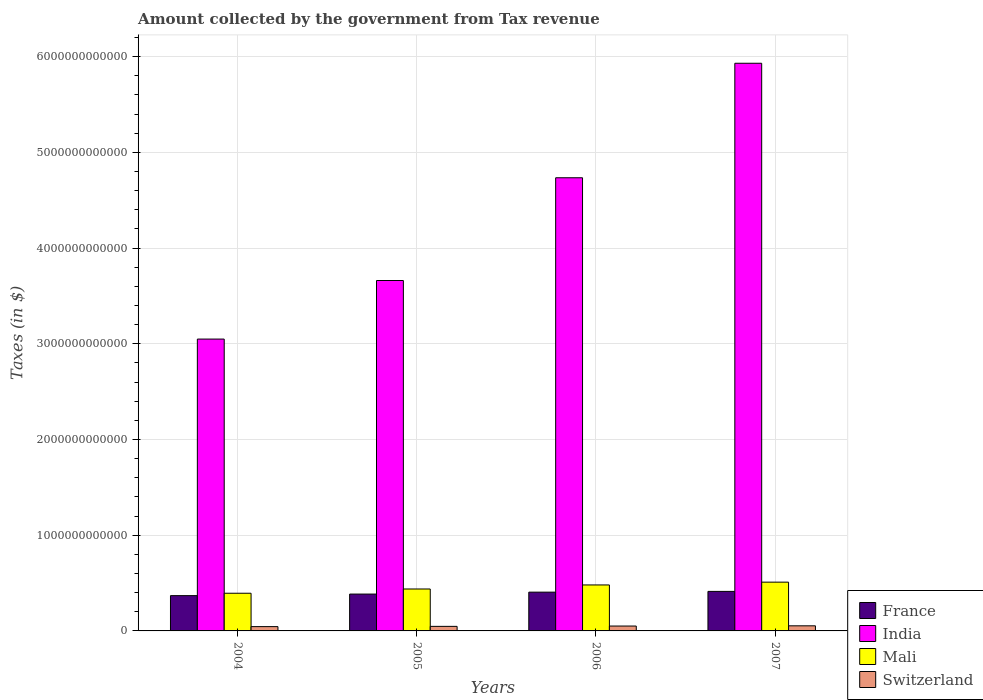Are the number of bars on each tick of the X-axis equal?
Your answer should be very brief. Yes. How many bars are there on the 3rd tick from the left?
Offer a terse response. 4. What is the label of the 3rd group of bars from the left?
Provide a succinct answer. 2006. In how many cases, is the number of bars for a given year not equal to the number of legend labels?
Offer a terse response. 0. What is the amount collected by the government from tax revenue in Switzerland in 2006?
Make the answer very short. 5.10e+1. Across all years, what is the maximum amount collected by the government from tax revenue in France?
Your response must be concise. 4.13e+11. Across all years, what is the minimum amount collected by the government from tax revenue in Mali?
Offer a very short reply. 3.94e+11. In which year was the amount collected by the government from tax revenue in Switzerland minimum?
Offer a very short reply. 2004. What is the total amount collected by the government from tax revenue in Switzerland in the graph?
Make the answer very short. 1.97e+11. What is the difference between the amount collected by the government from tax revenue in Mali in 2005 and that in 2007?
Offer a terse response. -7.16e+1. What is the difference between the amount collected by the government from tax revenue in India in 2005 and the amount collected by the government from tax revenue in France in 2004?
Offer a terse response. 3.29e+12. What is the average amount collected by the government from tax revenue in Mali per year?
Keep it short and to the point. 4.55e+11. In the year 2004, what is the difference between the amount collected by the government from tax revenue in France and amount collected by the government from tax revenue in Mali?
Ensure brevity in your answer.  -2.50e+1. In how many years, is the amount collected by the government from tax revenue in Mali greater than 1600000000000 $?
Your response must be concise. 0. What is the ratio of the amount collected by the government from tax revenue in Switzerland in 2005 to that in 2007?
Your response must be concise. 0.89. What is the difference between the highest and the second highest amount collected by the government from tax revenue in India?
Provide a succinct answer. 1.20e+12. What is the difference between the highest and the lowest amount collected by the government from tax revenue in Mali?
Your answer should be compact. 1.16e+11. What does the 4th bar from the left in 2005 represents?
Your response must be concise. Switzerland. What does the 2nd bar from the right in 2006 represents?
Provide a succinct answer. Mali. How many bars are there?
Your response must be concise. 16. What is the difference between two consecutive major ticks on the Y-axis?
Give a very brief answer. 1.00e+12. Are the values on the major ticks of Y-axis written in scientific E-notation?
Give a very brief answer. No. Does the graph contain grids?
Offer a terse response. Yes. How many legend labels are there?
Keep it short and to the point. 4. What is the title of the graph?
Offer a terse response. Amount collected by the government from Tax revenue. What is the label or title of the X-axis?
Ensure brevity in your answer.  Years. What is the label or title of the Y-axis?
Provide a short and direct response. Taxes (in $). What is the Taxes (in $) in France in 2004?
Your answer should be compact. 3.69e+11. What is the Taxes (in $) of India in 2004?
Your answer should be very brief. 3.05e+12. What is the Taxes (in $) in Mali in 2004?
Provide a succinct answer. 3.94e+11. What is the Taxes (in $) in Switzerland in 2004?
Your answer should be very brief. 4.49e+1. What is the Taxes (in $) of France in 2005?
Your answer should be very brief. 3.85e+11. What is the Taxes (in $) in India in 2005?
Offer a terse response. 3.66e+12. What is the Taxes (in $) of Mali in 2005?
Ensure brevity in your answer.  4.38e+11. What is the Taxes (in $) of Switzerland in 2005?
Your answer should be compact. 4.76e+1. What is the Taxes (in $) of France in 2006?
Provide a succinct answer. 4.05e+11. What is the Taxes (in $) of India in 2006?
Your response must be concise. 4.74e+12. What is the Taxes (in $) in Mali in 2006?
Give a very brief answer. 4.80e+11. What is the Taxes (in $) in Switzerland in 2006?
Keep it short and to the point. 5.10e+1. What is the Taxes (in $) in France in 2007?
Keep it short and to the point. 4.13e+11. What is the Taxes (in $) in India in 2007?
Give a very brief answer. 5.93e+12. What is the Taxes (in $) in Mali in 2007?
Give a very brief answer. 5.10e+11. What is the Taxes (in $) in Switzerland in 2007?
Your answer should be compact. 5.34e+1. Across all years, what is the maximum Taxes (in $) of France?
Your answer should be compact. 4.13e+11. Across all years, what is the maximum Taxes (in $) in India?
Your answer should be compact. 5.93e+12. Across all years, what is the maximum Taxes (in $) in Mali?
Offer a very short reply. 5.10e+11. Across all years, what is the maximum Taxes (in $) of Switzerland?
Offer a very short reply. 5.34e+1. Across all years, what is the minimum Taxes (in $) of France?
Ensure brevity in your answer.  3.69e+11. Across all years, what is the minimum Taxes (in $) of India?
Provide a succinct answer. 3.05e+12. Across all years, what is the minimum Taxes (in $) in Mali?
Keep it short and to the point. 3.94e+11. Across all years, what is the minimum Taxes (in $) in Switzerland?
Provide a succinct answer. 4.49e+1. What is the total Taxes (in $) of France in the graph?
Offer a terse response. 1.57e+12. What is the total Taxes (in $) in India in the graph?
Your response must be concise. 1.74e+13. What is the total Taxes (in $) in Mali in the graph?
Provide a short and direct response. 1.82e+12. What is the total Taxes (in $) in Switzerland in the graph?
Ensure brevity in your answer.  1.97e+11. What is the difference between the Taxes (in $) in France in 2004 and that in 2005?
Your answer should be very brief. -1.64e+1. What is the difference between the Taxes (in $) in India in 2004 and that in 2005?
Ensure brevity in your answer.  -6.12e+11. What is the difference between the Taxes (in $) in Mali in 2004 and that in 2005?
Your answer should be compact. -4.44e+1. What is the difference between the Taxes (in $) of Switzerland in 2004 and that in 2005?
Keep it short and to the point. -2.68e+09. What is the difference between the Taxes (in $) in France in 2004 and that in 2006?
Offer a terse response. -3.65e+1. What is the difference between the Taxes (in $) of India in 2004 and that in 2006?
Your answer should be compact. -1.69e+12. What is the difference between the Taxes (in $) of Mali in 2004 and that in 2006?
Your response must be concise. -8.68e+1. What is the difference between the Taxes (in $) in Switzerland in 2004 and that in 2006?
Offer a terse response. -6.07e+09. What is the difference between the Taxes (in $) in France in 2004 and that in 2007?
Keep it short and to the point. -4.43e+1. What is the difference between the Taxes (in $) of India in 2004 and that in 2007?
Keep it short and to the point. -2.88e+12. What is the difference between the Taxes (in $) of Mali in 2004 and that in 2007?
Your answer should be very brief. -1.16e+11. What is the difference between the Taxes (in $) of Switzerland in 2004 and that in 2007?
Keep it short and to the point. -8.41e+09. What is the difference between the Taxes (in $) of France in 2005 and that in 2006?
Provide a succinct answer. -2.01e+1. What is the difference between the Taxes (in $) in India in 2005 and that in 2006?
Your answer should be very brief. -1.07e+12. What is the difference between the Taxes (in $) of Mali in 2005 and that in 2006?
Your response must be concise. -4.23e+1. What is the difference between the Taxes (in $) of Switzerland in 2005 and that in 2006?
Give a very brief answer. -3.39e+09. What is the difference between the Taxes (in $) in France in 2005 and that in 2007?
Give a very brief answer. -2.78e+1. What is the difference between the Taxes (in $) of India in 2005 and that in 2007?
Your answer should be compact. -2.27e+12. What is the difference between the Taxes (in $) in Mali in 2005 and that in 2007?
Your answer should be very brief. -7.16e+1. What is the difference between the Taxes (in $) in Switzerland in 2005 and that in 2007?
Offer a terse response. -5.73e+09. What is the difference between the Taxes (in $) in France in 2006 and that in 2007?
Provide a succinct answer. -7.79e+09. What is the difference between the Taxes (in $) of India in 2006 and that in 2007?
Make the answer very short. -1.20e+12. What is the difference between the Taxes (in $) of Mali in 2006 and that in 2007?
Your response must be concise. -2.93e+1. What is the difference between the Taxes (in $) of Switzerland in 2006 and that in 2007?
Make the answer very short. -2.34e+09. What is the difference between the Taxes (in $) in France in 2004 and the Taxes (in $) in India in 2005?
Make the answer very short. -3.29e+12. What is the difference between the Taxes (in $) in France in 2004 and the Taxes (in $) in Mali in 2005?
Offer a terse response. -6.94e+1. What is the difference between the Taxes (in $) in France in 2004 and the Taxes (in $) in Switzerland in 2005?
Your answer should be very brief. 3.21e+11. What is the difference between the Taxes (in $) of India in 2004 and the Taxes (in $) of Mali in 2005?
Offer a terse response. 2.61e+12. What is the difference between the Taxes (in $) in India in 2004 and the Taxes (in $) in Switzerland in 2005?
Your answer should be compact. 3.00e+12. What is the difference between the Taxes (in $) in Mali in 2004 and the Taxes (in $) in Switzerland in 2005?
Your answer should be very brief. 3.46e+11. What is the difference between the Taxes (in $) of France in 2004 and the Taxes (in $) of India in 2006?
Ensure brevity in your answer.  -4.37e+12. What is the difference between the Taxes (in $) of France in 2004 and the Taxes (in $) of Mali in 2006?
Provide a succinct answer. -1.12e+11. What is the difference between the Taxes (in $) in France in 2004 and the Taxes (in $) in Switzerland in 2006?
Provide a short and direct response. 3.18e+11. What is the difference between the Taxes (in $) of India in 2004 and the Taxes (in $) of Mali in 2006?
Give a very brief answer. 2.57e+12. What is the difference between the Taxes (in $) of India in 2004 and the Taxes (in $) of Switzerland in 2006?
Give a very brief answer. 3.00e+12. What is the difference between the Taxes (in $) of Mali in 2004 and the Taxes (in $) of Switzerland in 2006?
Your answer should be compact. 3.43e+11. What is the difference between the Taxes (in $) of France in 2004 and the Taxes (in $) of India in 2007?
Your answer should be very brief. -5.56e+12. What is the difference between the Taxes (in $) in France in 2004 and the Taxes (in $) in Mali in 2007?
Offer a terse response. -1.41e+11. What is the difference between the Taxes (in $) of France in 2004 and the Taxes (in $) of Switzerland in 2007?
Your response must be concise. 3.15e+11. What is the difference between the Taxes (in $) of India in 2004 and the Taxes (in $) of Mali in 2007?
Provide a succinct answer. 2.54e+12. What is the difference between the Taxes (in $) in India in 2004 and the Taxes (in $) in Switzerland in 2007?
Offer a very short reply. 3.00e+12. What is the difference between the Taxes (in $) in Mali in 2004 and the Taxes (in $) in Switzerland in 2007?
Your answer should be very brief. 3.40e+11. What is the difference between the Taxes (in $) of France in 2005 and the Taxes (in $) of India in 2006?
Offer a terse response. -4.35e+12. What is the difference between the Taxes (in $) of France in 2005 and the Taxes (in $) of Mali in 2006?
Your answer should be compact. -9.53e+1. What is the difference between the Taxes (in $) in France in 2005 and the Taxes (in $) in Switzerland in 2006?
Offer a terse response. 3.34e+11. What is the difference between the Taxes (in $) of India in 2005 and the Taxes (in $) of Mali in 2006?
Give a very brief answer. 3.18e+12. What is the difference between the Taxes (in $) in India in 2005 and the Taxes (in $) in Switzerland in 2006?
Your answer should be compact. 3.61e+12. What is the difference between the Taxes (in $) of Mali in 2005 and the Taxes (in $) of Switzerland in 2006?
Your answer should be very brief. 3.87e+11. What is the difference between the Taxes (in $) of France in 2005 and the Taxes (in $) of India in 2007?
Ensure brevity in your answer.  -5.55e+12. What is the difference between the Taxes (in $) in France in 2005 and the Taxes (in $) in Mali in 2007?
Your response must be concise. -1.25e+11. What is the difference between the Taxes (in $) of France in 2005 and the Taxes (in $) of Switzerland in 2007?
Ensure brevity in your answer.  3.32e+11. What is the difference between the Taxes (in $) of India in 2005 and the Taxes (in $) of Mali in 2007?
Ensure brevity in your answer.  3.15e+12. What is the difference between the Taxes (in $) in India in 2005 and the Taxes (in $) in Switzerland in 2007?
Provide a short and direct response. 3.61e+12. What is the difference between the Taxes (in $) in Mali in 2005 and the Taxes (in $) in Switzerland in 2007?
Your answer should be very brief. 3.85e+11. What is the difference between the Taxes (in $) of France in 2006 and the Taxes (in $) of India in 2007?
Provide a short and direct response. -5.53e+12. What is the difference between the Taxes (in $) in France in 2006 and the Taxes (in $) in Mali in 2007?
Offer a very short reply. -1.05e+11. What is the difference between the Taxes (in $) in France in 2006 and the Taxes (in $) in Switzerland in 2007?
Provide a short and direct response. 3.52e+11. What is the difference between the Taxes (in $) of India in 2006 and the Taxes (in $) of Mali in 2007?
Provide a short and direct response. 4.23e+12. What is the difference between the Taxes (in $) of India in 2006 and the Taxes (in $) of Switzerland in 2007?
Make the answer very short. 4.68e+12. What is the difference between the Taxes (in $) of Mali in 2006 and the Taxes (in $) of Switzerland in 2007?
Offer a very short reply. 4.27e+11. What is the average Taxes (in $) of France per year?
Keep it short and to the point. 3.93e+11. What is the average Taxes (in $) of India per year?
Make the answer very short. 4.34e+12. What is the average Taxes (in $) of Mali per year?
Your answer should be very brief. 4.55e+11. What is the average Taxes (in $) in Switzerland per year?
Give a very brief answer. 4.92e+1. In the year 2004, what is the difference between the Taxes (in $) in France and Taxes (in $) in India?
Your answer should be very brief. -2.68e+12. In the year 2004, what is the difference between the Taxes (in $) in France and Taxes (in $) in Mali?
Your answer should be compact. -2.50e+1. In the year 2004, what is the difference between the Taxes (in $) of France and Taxes (in $) of Switzerland?
Your answer should be compact. 3.24e+11. In the year 2004, what is the difference between the Taxes (in $) in India and Taxes (in $) in Mali?
Keep it short and to the point. 2.66e+12. In the year 2004, what is the difference between the Taxes (in $) in India and Taxes (in $) in Switzerland?
Make the answer very short. 3.00e+12. In the year 2004, what is the difference between the Taxes (in $) in Mali and Taxes (in $) in Switzerland?
Your response must be concise. 3.49e+11. In the year 2005, what is the difference between the Taxes (in $) in France and Taxes (in $) in India?
Provide a short and direct response. -3.28e+12. In the year 2005, what is the difference between the Taxes (in $) of France and Taxes (in $) of Mali?
Offer a terse response. -5.30e+1. In the year 2005, what is the difference between the Taxes (in $) of France and Taxes (in $) of Switzerland?
Your answer should be very brief. 3.37e+11. In the year 2005, what is the difference between the Taxes (in $) in India and Taxes (in $) in Mali?
Give a very brief answer. 3.22e+12. In the year 2005, what is the difference between the Taxes (in $) in India and Taxes (in $) in Switzerland?
Make the answer very short. 3.61e+12. In the year 2005, what is the difference between the Taxes (in $) of Mali and Taxes (in $) of Switzerland?
Offer a very short reply. 3.90e+11. In the year 2006, what is the difference between the Taxes (in $) of France and Taxes (in $) of India?
Your answer should be very brief. -4.33e+12. In the year 2006, what is the difference between the Taxes (in $) of France and Taxes (in $) of Mali?
Provide a short and direct response. -7.53e+1. In the year 2006, what is the difference between the Taxes (in $) of France and Taxes (in $) of Switzerland?
Make the answer very short. 3.54e+11. In the year 2006, what is the difference between the Taxes (in $) of India and Taxes (in $) of Mali?
Your response must be concise. 4.25e+12. In the year 2006, what is the difference between the Taxes (in $) in India and Taxes (in $) in Switzerland?
Ensure brevity in your answer.  4.68e+12. In the year 2006, what is the difference between the Taxes (in $) of Mali and Taxes (in $) of Switzerland?
Provide a short and direct response. 4.29e+11. In the year 2007, what is the difference between the Taxes (in $) in France and Taxes (in $) in India?
Offer a terse response. -5.52e+12. In the year 2007, what is the difference between the Taxes (in $) in France and Taxes (in $) in Mali?
Your response must be concise. -9.67e+1. In the year 2007, what is the difference between the Taxes (in $) in France and Taxes (in $) in Switzerland?
Your answer should be compact. 3.60e+11. In the year 2007, what is the difference between the Taxes (in $) of India and Taxes (in $) of Mali?
Provide a succinct answer. 5.42e+12. In the year 2007, what is the difference between the Taxes (in $) of India and Taxes (in $) of Switzerland?
Your answer should be compact. 5.88e+12. In the year 2007, what is the difference between the Taxes (in $) in Mali and Taxes (in $) in Switzerland?
Offer a terse response. 4.56e+11. What is the ratio of the Taxes (in $) in France in 2004 to that in 2005?
Make the answer very short. 0.96. What is the ratio of the Taxes (in $) of India in 2004 to that in 2005?
Your answer should be very brief. 0.83. What is the ratio of the Taxes (in $) in Mali in 2004 to that in 2005?
Give a very brief answer. 0.9. What is the ratio of the Taxes (in $) in Switzerland in 2004 to that in 2005?
Provide a short and direct response. 0.94. What is the ratio of the Taxes (in $) of France in 2004 to that in 2006?
Offer a terse response. 0.91. What is the ratio of the Taxes (in $) in India in 2004 to that in 2006?
Your response must be concise. 0.64. What is the ratio of the Taxes (in $) in Mali in 2004 to that in 2006?
Ensure brevity in your answer.  0.82. What is the ratio of the Taxes (in $) of Switzerland in 2004 to that in 2006?
Provide a short and direct response. 0.88. What is the ratio of the Taxes (in $) of France in 2004 to that in 2007?
Give a very brief answer. 0.89. What is the ratio of the Taxes (in $) in India in 2004 to that in 2007?
Offer a terse response. 0.51. What is the ratio of the Taxes (in $) of Mali in 2004 to that in 2007?
Your response must be concise. 0.77. What is the ratio of the Taxes (in $) in Switzerland in 2004 to that in 2007?
Your answer should be compact. 0.84. What is the ratio of the Taxes (in $) of France in 2005 to that in 2006?
Keep it short and to the point. 0.95. What is the ratio of the Taxes (in $) of India in 2005 to that in 2006?
Your answer should be compact. 0.77. What is the ratio of the Taxes (in $) in Mali in 2005 to that in 2006?
Your answer should be very brief. 0.91. What is the ratio of the Taxes (in $) of Switzerland in 2005 to that in 2006?
Your response must be concise. 0.93. What is the ratio of the Taxes (in $) in France in 2005 to that in 2007?
Keep it short and to the point. 0.93. What is the ratio of the Taxes (in $) of India in 2005 to that in 2007?
Offer a terse response. 0.62. What is the ratio of the Taxes (in $) in Mali in 2005 to that in 2007?
Your response must be concise. 0.86. What is the ratio of the Taxes (in $) in Switzerland in 2005 to that in 2007?
Your answer should be compact. 0.89. What is the ratio of the Taxes (in $) in France in 2006 to that in 2007?
Offer a very short reply. 0.98. What is the ratio of the Taxes (in $) of India in 2006 to that in 2007?
Your answer should be very brief. 0.8. What is the ratio of the Taxes (in $) in Mali in 2006 to that in 2007?
Give a very brief answer. 0.94. What is the ratio of the Taxes (in $) in Switzerland in 2006 to that in 2007?
Your answer should be compact. 0.96. What is the difference between the highest and the second highest Taxes (in $) of France?
Your response must be concise. 7.79e+09. What is the difference between the highest and the second highest Taxes (in $) in India?
Offer a terse response. 1.20e+12. What is the difference between the highest and the second highest Taxes (in $) in Mali?
Your answer should be very brief. 2.93e+1. What is the difference between the highest and the second highest Taxes (in $) of Switzerland?
Make the answer very short. 2.34e+09. What is the difference between the highest and the lowest Taxes (in $) in France?
Make the answer very short. 4.43e+1. What is the difference between the highest and the lowest Taxes (in $) of India?
Provide a succinct answer. 2.88e+12. What is the difference between the highest and the lowest Taxes (in $) of Mali?
Offer a very short reply. 1.16e+11. What is the difference between the highest and the lowest Taxes (in $) of Switzerland?
Provide a succinct answer. 8.41e+09. 